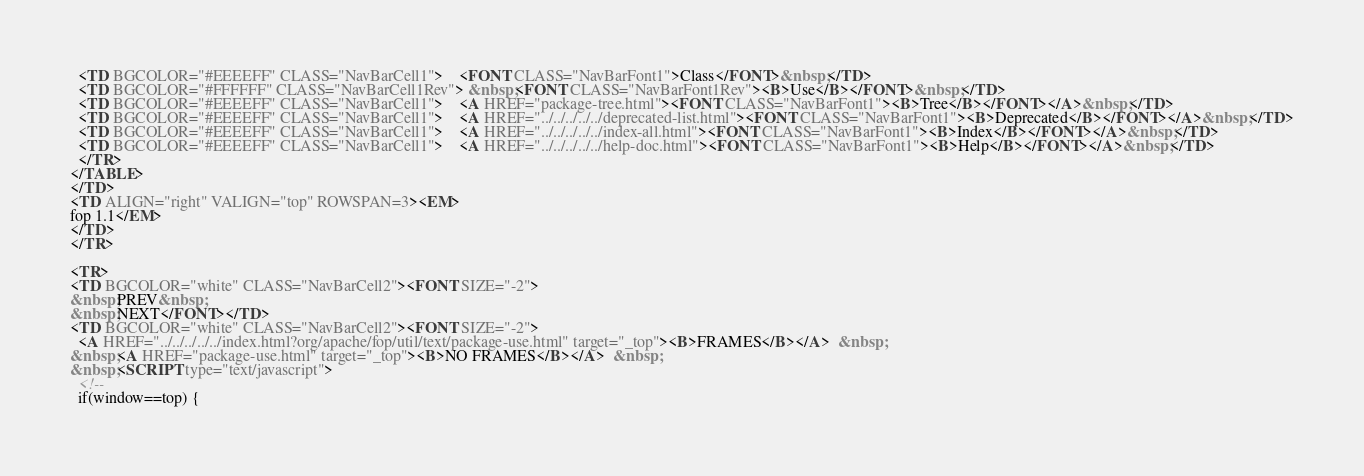Convert code to text. <code><loc_0><loc_0><loc_500><loc_500><_HTML_>  <TD BGCOLOR="#EEEEFF" CLASS="NavBarCell1">    <FONT CLASS="NavBarFont1">Class</FONT>&nbsp;</TD>
  <TD BGCOLOR="#FFFFFF" CLASS="NavBarCell1Rev"> &nbsp;<FONT CLASS="NavBarFont1Rev"><B>Use</B></FONT>&nbsp;</TD>
  <TD BGCOLOR="#EEEEFF" CLASS="NavBarCell1">    <A HREF="package-tree.html"><FONT CLASS="NavBarFont1"><B>Tree</B></FONT></A>&nbsp;</TD>
  <TD BGCOLOR="#EEEEFF" CLASS="NavBarCell1">    <A HREF="../../../../../deprecated-list.html"><FONT CLASS="NavBarFont1"><B>Deprecated</B></FONT></A>&nbsp;</TD>
  <TD BGCOLOR="#EEEEFF" CLASS="NavBarCell1">    <A HREF="../../../../../index-all.html"><FONT CLASS="NavBarFont1"><B>Index</B></FONT></A>&nbsp;</TD>
  <TD BGCOLOR="#EEEEFF" CLASS="NavBarCell1">    <A HREF="../../../../../help-doc.html"><FONT CLASS="NavBarFont1"><B>Help</B></FONT></A>&nbsp;</TD>
  </TR>
</TABLE>
</TD>
<TD ALIGN="right" VALIGN="top" ROWSPAN=3><EM>
fop 1.1</EM>
</TD>
</TR>

<TR>
<TD BGCOLOR="white" CLASS="NavBarCell2"><FONT SIZE="-2">
&nbsp;PREV&nbsp;
&nbsp;NEXT</FONT></TD>
<TD BGCOLOR="white" CLASS="NavBarCell2"><FONT SIZE="-2">
  <A HREF="../../../../../index.html?org/apache/fop/util/text/package-use.html" target="_top"><B>FRAMES</B></A>  &nbsp;
&nbsp;<A HREF="package-use.html" target="_top"><B>NO FRAMES</B></A>  &nbsp;
&nbsp;<SCRIPT type="text/javascript">
  <!--
  if(window==top) {</code> 